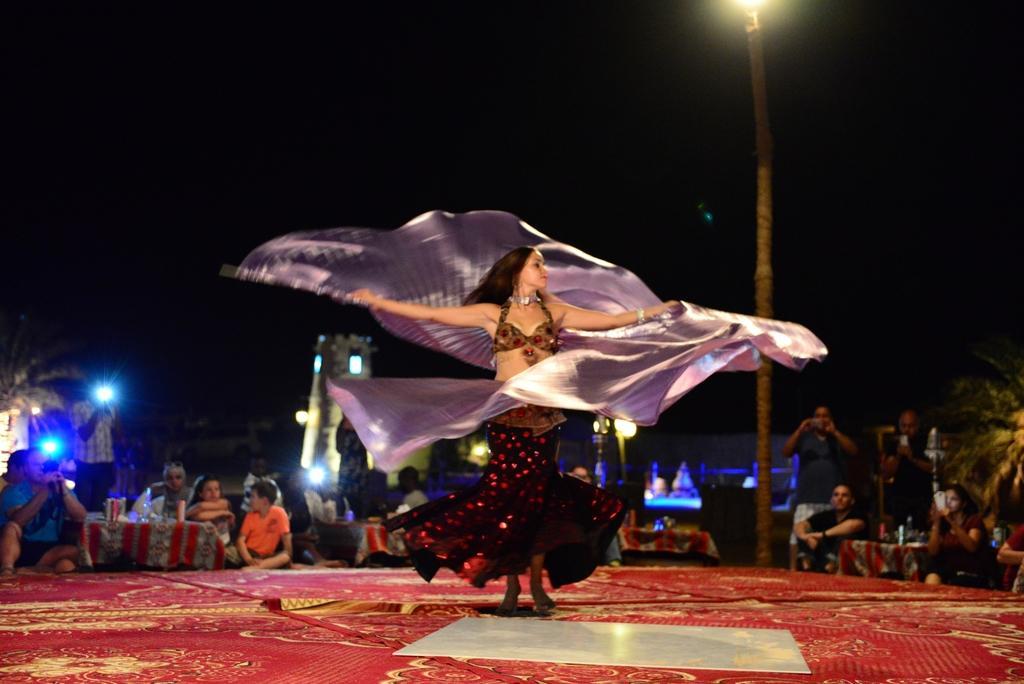Describe this image in one or two sentences. This is an image clicked in the dark. In the middle of the image I can see a woman is dancing on the floor by holding a cloth in the hands. In the background, I can see few people are sitting on the floor and looking at this woman and also I can see few trees and lights. The background is in black color. 